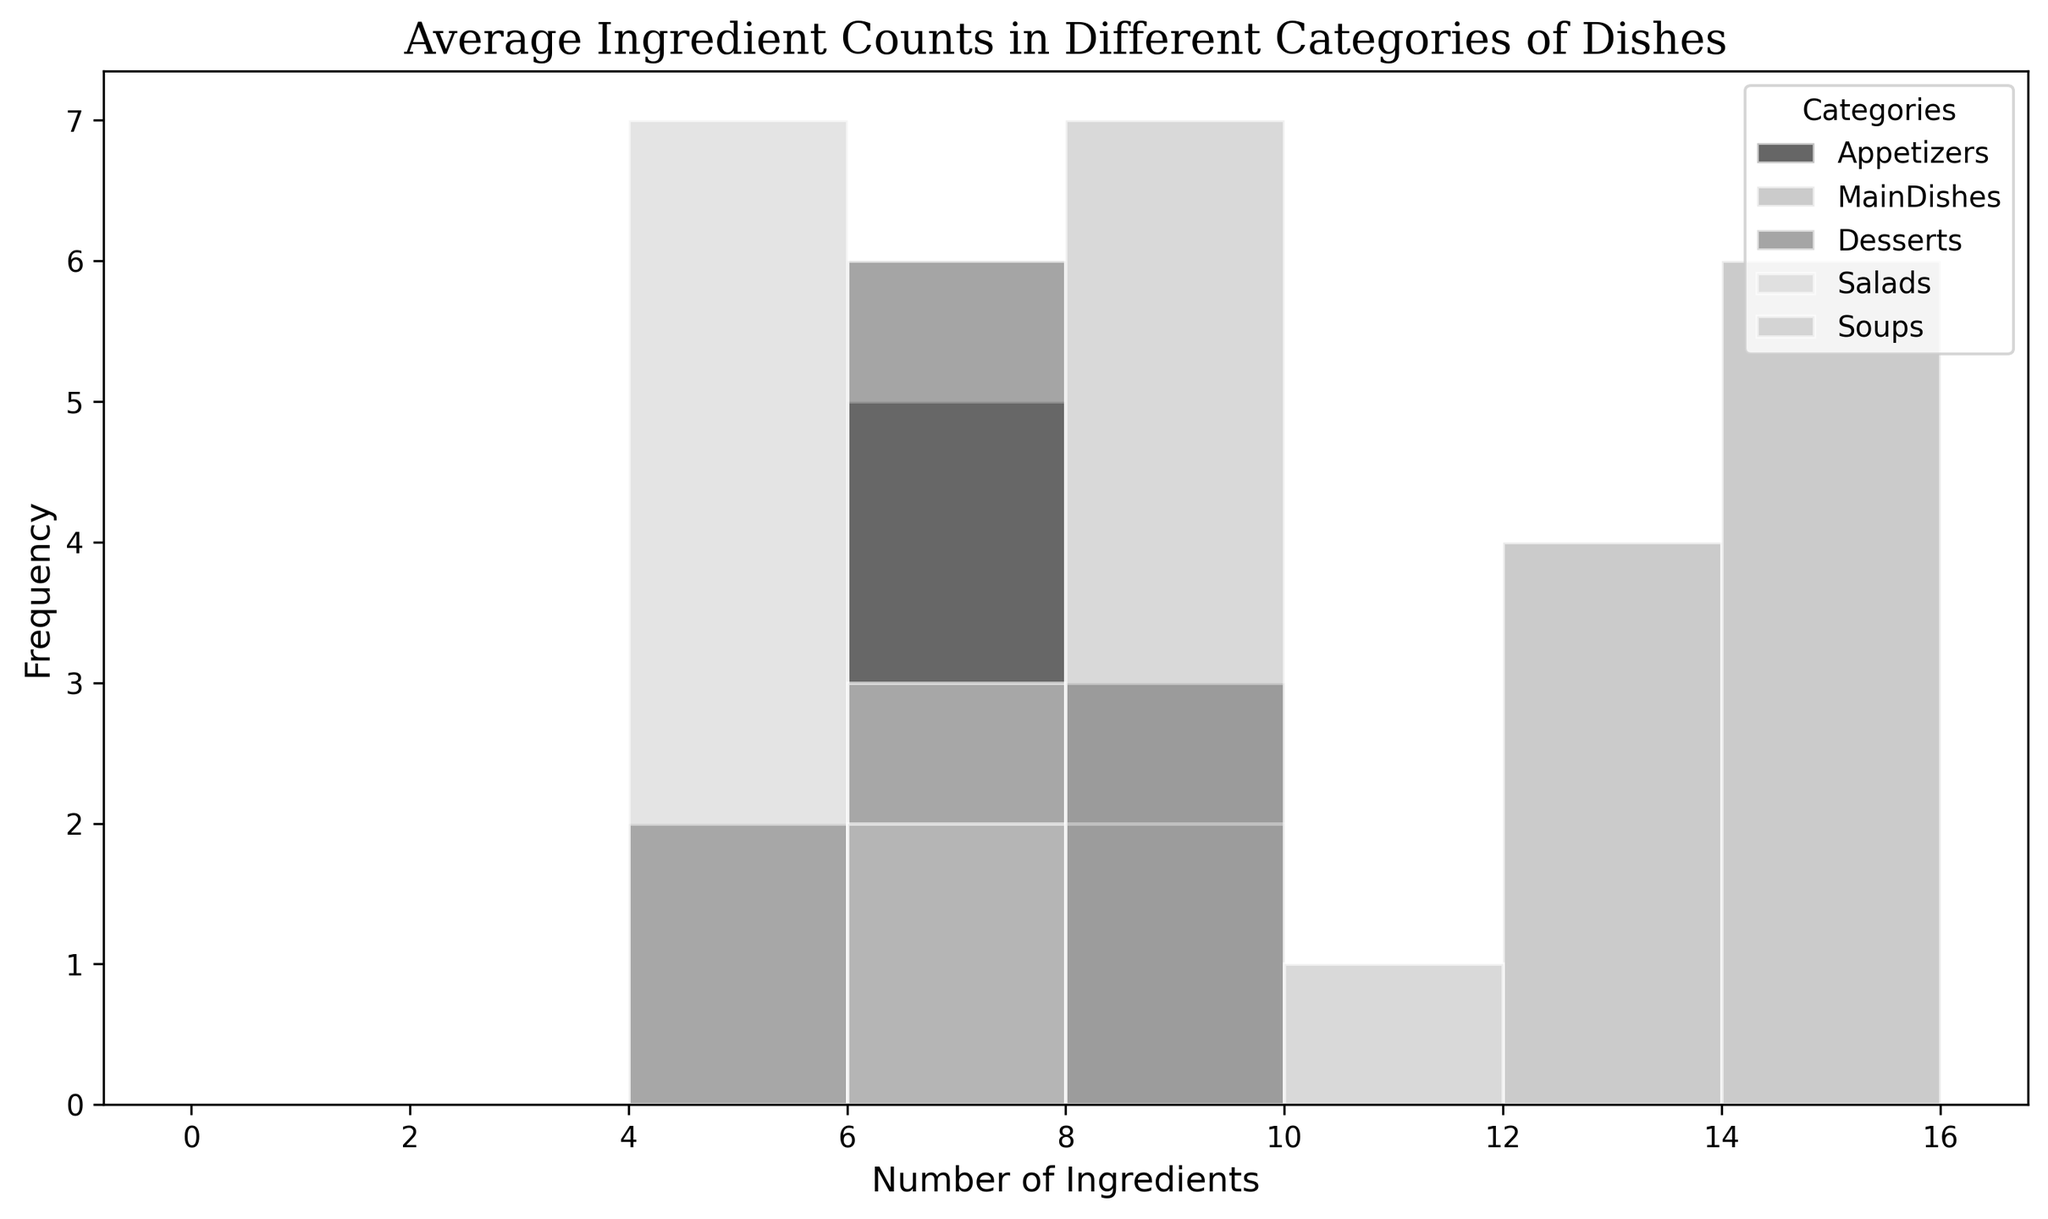What's the most frequent number of ingredients in MainDishes? Look at the histogram for "MainDishes." The tallest bar represents the number of ingredients that appears most frequently.
Answer: 14 Which category has the widest range of ingredient counts? Examine the spread of the bars for each category. The "MainDishes" category has bars spanning from 12 to 16, which is the widest range.
Answer: MainDishes Among Appetizers and Desserts, which has a higher average number of ingredients? Compare the central tendency of the "Appetizers" and "Desserts" histograms. "Appetizers" mostly range from 5 to 9, whereas "Desserts" mostly range from 5 to 8. This implies that "Appetizers" have a slightly higher average number of ingredients.
Answer: Appetizers In which category do the majority of dishes have 7 ingredients? Look for the tallest bar in the histogram near the value "7." Both "Appetizers" and "Desserts" have tall bars around 7 ingredients, but "Appetizers" has a higher frequency.
Answer: Appetizers What’s the least frequent number of ingredients in Soups? Identify the shortest bar in the "Soups" histogram. The shortest bar corresponds to 10 ingredients.
Answer: 10 Do any categories have a number of ingredients that appear exactly once? Check for any single bars standing alone for each category. In "Soups," the number 10 ingredients appears to be a single standalone bar.
Answer: Yes, Soups Which category has the least overlap with other categories in terms of ingredient counts? Observe the histograms and see which category's ingredients counts do not significantly overlap with others. The "MainDishes" category, ranging above 12, has the least overlap.
Answer: MainDishes What is the most frequent number of ingredients in Desserts and Salads combined? Combine the frequency of counts for both "Desserts" and "Salads" categories. Both categories have their highest frequencies at 5 and 6 ingredients. Since they both peak at the same ingredients count, they share the answer.
Answer: 5 Which category has a higher frequency of dishes with ingredients between 4 and 6? Evaluate the stacked frequency (or heights of bars) for the "4 to 6 ingredients" bins for each category. "Salads" has consistent bars between 4 to 6. These consistently high bars indicate a higher frequency.
Answer: Salads 